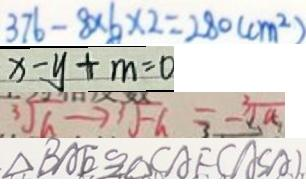Convert formula to latex. <formula><loc_0><loc_0><loc_500><loc_500>3 7 6 - 8 \times 6 \times 2 = 2 8 0 ( c m ^ { 2 } ) 
 x - y + m = 0 
 \sqrt [ 3 ] { a } \rightarrow 3 \sqrt { - a } = - \sqrt [ 3 ] { a } 
 \Delta B A E \cong \Delta C A F ( A S A )</formula> 